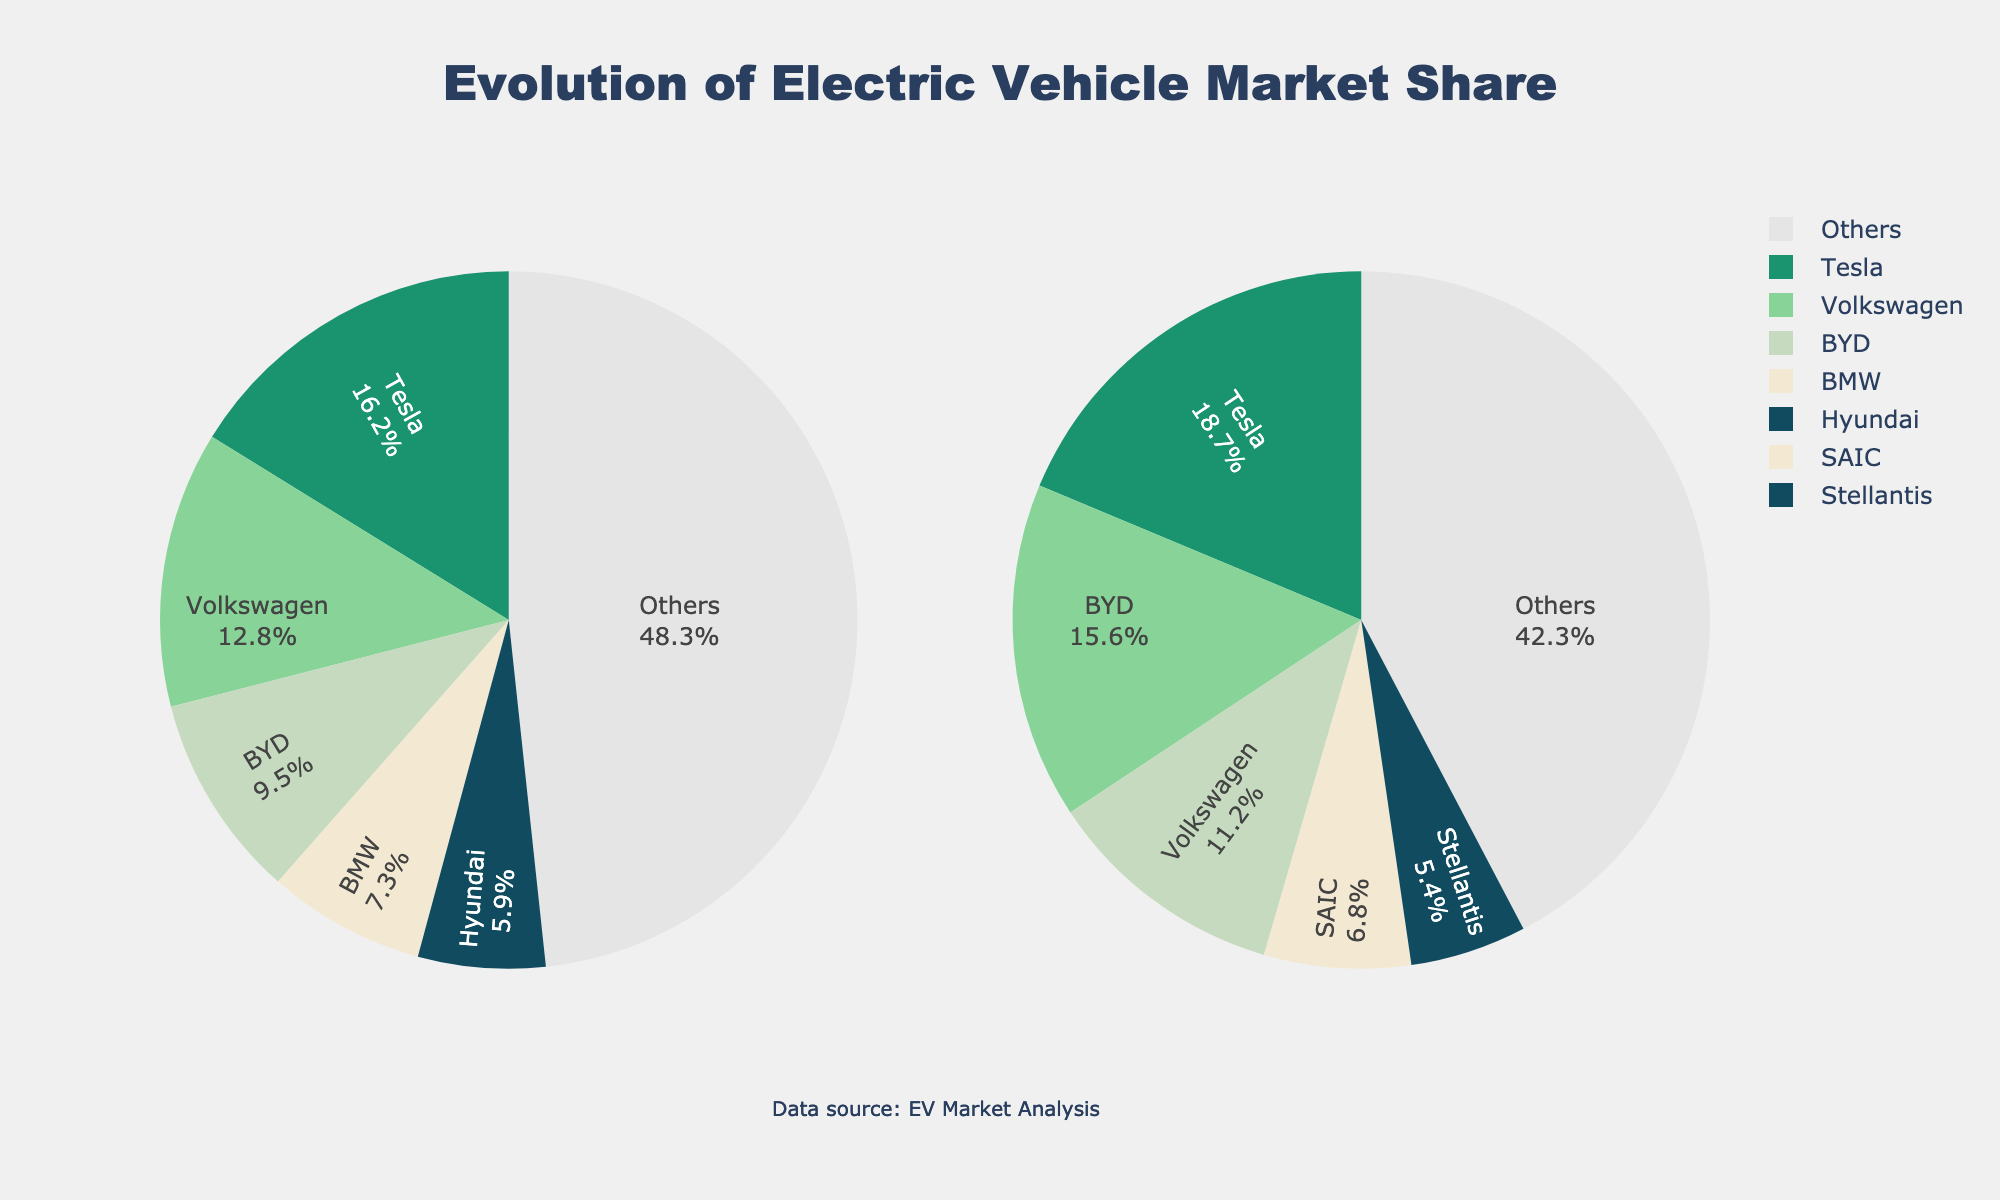Which manufacturer had the largest market share in 2020? In the 2020 pie chart, Tesla occupies the largest segment of the pie chart, indicating that it had the highest market share.
Answer: Tesla What is the combined market share of Tesla and BYD in 2022? Tesla's market share in 2022 is shown as 18.7%, and BYD's is 15.6%. Adding these values gives us 18.7 + 15.6 = 34.3%.
Answer: 34.3% Which manufacturer saw an increase in market share from 2020 to 2022? Comparing the pie charts for 2020 and 2022, Tesla's market share increased from 16.2% to 18.7%, and BYD's increased from 9.5% to 15.6%.
Answer: Tesla and BYD What is the market share difference between Volkswagen in 2020 and 2022? Volkswagen's market share in 2020 is 12.8%, and in 2022 it is 11.2%. Subtracting these values gives us 12.8 - 11.2 = 1.6%.
Answer: 1.6% Which manufacturer was newly added to the pie chart in 2022? Comparing both pie charts, SAIC and Stellantis appear in 2022 but are not present in the 2020 pie chart.
Answer: SAIC and Stellantis Which year shows a higher combined market share for 'Others'? The 'Others' segment in 2020 has a market share of 48.3%, and in 2022 it is 42.3%. 48.3% is greater than 42.3%, so 2020 has a higher combined market share for 'Others.'
Answer: 2020 Which manufacturer had a reduced market share in 2022 compared to 2020? Volkswagen's market share dropped from 12.8% in 2020 to 11.2% in 2022, indicating a reduction.
Answer: Volkswagen What percentage of the market did Hyundai hold in 2020? By looking at the 2020 pie chart, Hyundai is shown holding 5.9% of the market.
Answer: 5.9% Which manufacturer had the third-largest market share in 2022? In the 2022 pie chart, BYD is the second largest, and Volkswagen is the third largest with 11.2%.
Answer: Volkswagen 